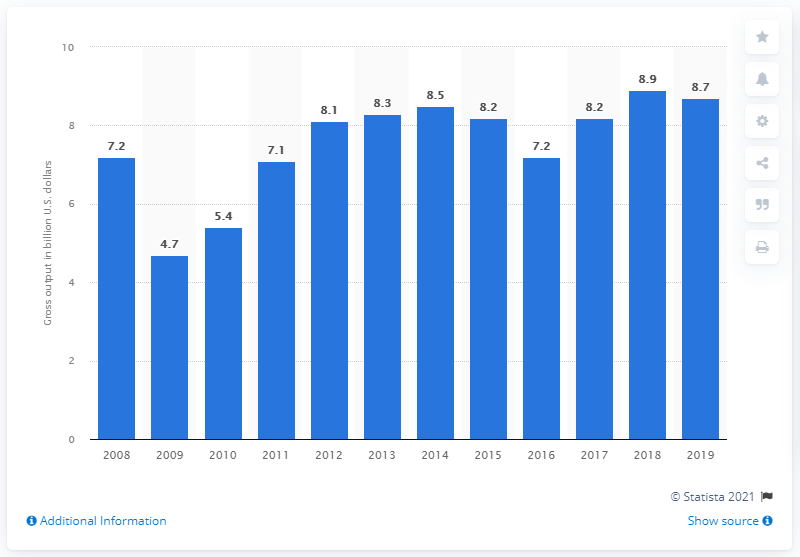List a handful of essential elements in this visual. In 2019, the gross output of the metal cutting and forming machine tool manufacturing sector was $8.7 billion. 